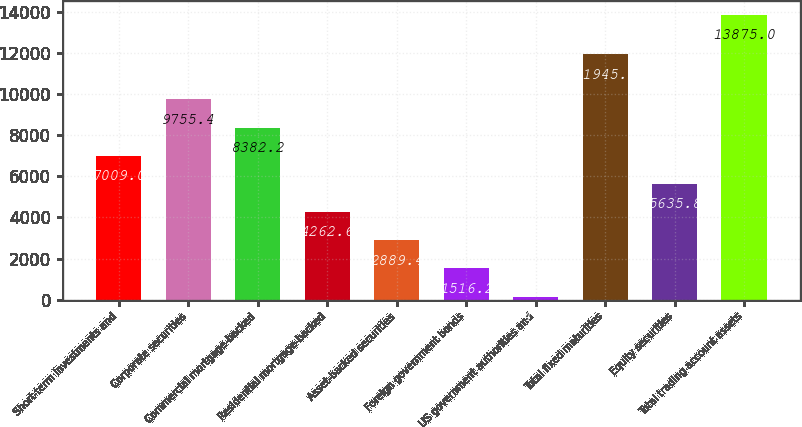Convert chart. <chart><loc_0><loc_0><loc_500><loc_500><bar_chart><fcel>Short-term investments and<fcel>Corporate securities<fcel>Commercial mortgage-backed<fcel>Residential mortgage-backed<fcel>Asset-backed securities<fcel>Foreign government bonds<fcel>US government authorities and<fcel>Total fixed maturities<fcel>Equity securities<fcel>Total trading account assets<nl><fcel>7009<fcel>9755.4<fcel>8382.2<fcel>4262.6<fcel>2889.4<fcel>1516.2<fcel>143<fcel>11945<fcel>5635.8<fcel>13875<nl></chart> 